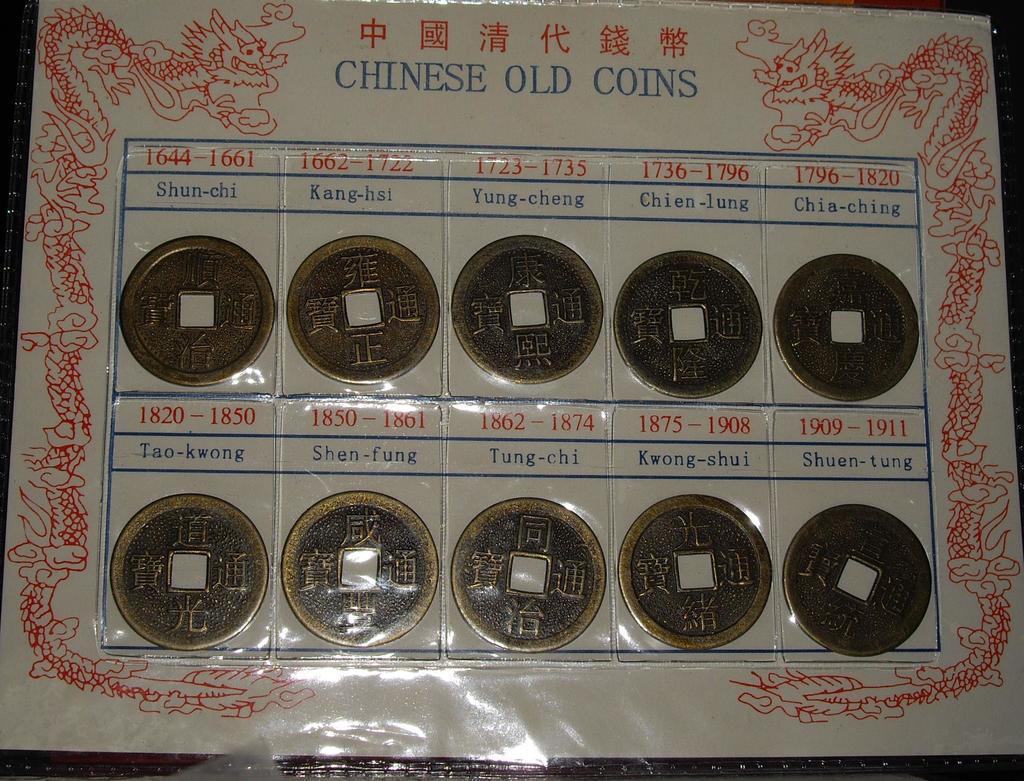<image>
Summarize the visual content of the image. A display of coins is  labeled Chinese old coins. 